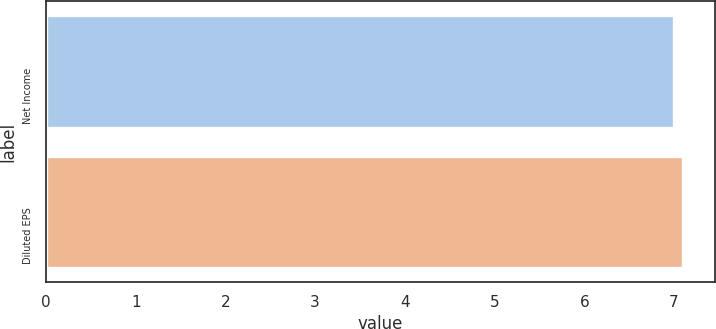Convert chart. <chart><loc_0><loc_0><loc_500><loc_500><bar_chart><fcel>Net Income<fcel>Diluted EPS<nl><fcel>7<fcel>7.1<nl></chart> 